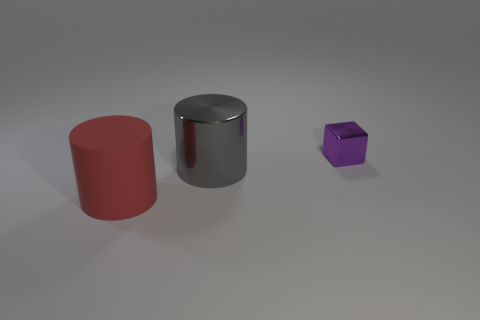Is there anything else that has the same material as the large red thing?
Your response must be concise. No. How many objects are in front of the small purple block and behind the large red rubber cylinder?
Make the answer very short. 1. What is the shape of the shiny object that is the same size as the red matte object?
Provide a short and direct response. Cylinder. What is the size of the purple block?
Ensure brevity in your answer.  Small. What is the material of the large object that is behind the object to the left of the metal object in front of the tiny object?
Your response must be concise. Metal. What is the color of the cylinder that is made of the same material as the small object?
Offer a terse response. Gray. There is a big cylinder that is behind the object in front of the gray shiny cylinder; how many large objects are in front of it?
Provide a succinct answer. 1. Are there any other things that are the same shape as the purple metallic thing?
Your answer should be very brief. No. How many objects are either cylinders behind the matte cylinder or purple metallic cubes?
Your answer should be compact. 2. There is a big thing that is in front of the cylinder that is on the right side of the large matte cylinder; what shape is it?
Offer a terse response. Cylinder. 